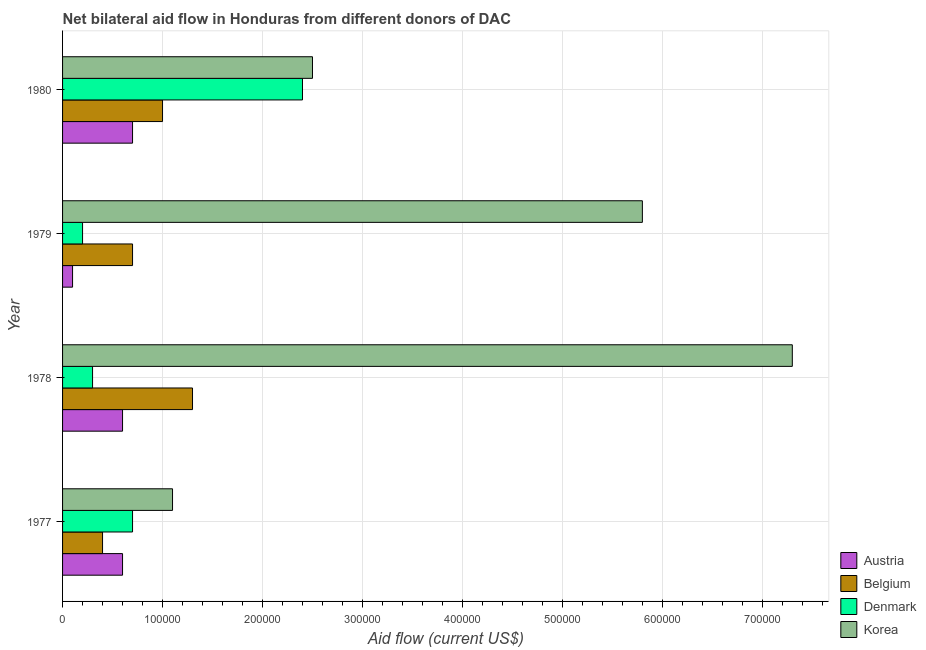How many different coloured bars are there?
Your answer should be very brief. 4. Are the number of bars per tick equal to the number of legend labels?
Your answer should be compact. Yes. Are the number of bars on each tick of the Y-axis equal?
Your answer should be compact. Yes. How many bars are there on the 1st tick from the top?
Keep it short and to the point. 4. How many bars are there on the 4th tick from the bottom?
Provide a short and direct response. 4. What is the label of the 3rd group of bars from the top?
Offer a very short reply. 1978. In how many cases, is the number of bars for a given year not equal to the number of legend labels?
Provide a succinct answer. 0. What is the amount of aid given by belgium in 1979?
Your answer should be compact. 7.00e+04. Across all years, what is the maximum amount of aid given by denmark?
Provide a succinct answer. 2.40e+05. Across all years, what is the minimum amount of aid given by denmark?
Ensure brevity in your answer.  2.00e+04. In which year was the amount of aid given by korea maximum?
Give a very brief answer. 1978. In which year was the amount of aid given by austria minimum?
Provide a short and direct response. 1979. What is the total amount of aid given by denmark in the graph?
Ensure brevity in your answer.  3.60e+05. What is the difference between the amount of aid given by denmark in 1979 and that in 1980?
Provide a succinct answer. -2.20e+05. What is the difference between the amount of aid given by korea in 1980 and the amount of aid given by austria in 1979?
Offer a very short reply. 2.40e+05. In the year 1979, what is the difference between the amount of aid given by korea and amount of aid given by belgium?
Your answer should be compact. 5.10e+05. What is the ratio of the amount of aid given by belgium in 1977 to that in 1979?
Make the answer very short. 0.57. Is the difference between the amount of aid given by korea in 1979 and 1980 greater than the difference between the amount of aid given by belgium in 1979 and 1980?
Your answer should be compact. Yes. What is the difference between the highest and the second highest amount of aid given by belgium?
Your answer should be compact. 3.00e+04. What is the difference between the highest and the lowest amount of aid given by austria?
Make the answer very short. 6.00e+04. Is it the case that in every year, the sum of the amount of aid given by denmark and amount of aid given by korea is greater than the sum of amount of aid given by austria and amount of aid given by belgium?
Provide a succinct answer. Yes. What does the 2nd bar from the top in 1979 represents?
Your answer should be very brief. Denmark. Is it the case that in every year, the sum of the amount of aid given by austria and amount of aid given by belgium is greater than the amount of aid given by denmark?
Offer a terse response. No. What is the difference between two consecutive major ticks on the X-axis?
Make the answer very short. 1.00e+05. Does the graph contain any zero values?
Your response must be concise. No. Where does the legend appear in the graph?
Give a very brief answer. Bottom right. How many legend labels are there?
Your answer should be very brief. 4. What is the title of the graph?
Offer a very short reply. Net bilateral aid flow in Honduras from different donors of DAC. Does "Rule based governance" appear as one of the legend labels in the graph?
Ensure brevity in your answer.  No. What is the label or title of the X-axis?
Your answer should be compact. Aid flow (current US$). What is the label or title of the Y-axis?
Provide a succinct answer. Year. What is the Aid flow (current US$) in Belgium in 1977?
Your answer should be very brief. 4.00e+04. What is the Aid flow (current US$) in Austria in 1978?
Offer a terse response. 6.00e+04. What is the Aid flow (current US$) of Korea in 1978?
Give a very brief answer. 7.30e+05. What is the Aid flow (current US$) in Austria in 1979?
Give a very brief answer. 10000. What is the Aid flow (current US$) in Korea in 1979?
Your response must be concise. 5.80e+05. What is the Aid flow (current US$) in Belgium in 1980?
Make the answer very short. 1.00e+05. What is the Aid flow (current US$) of Korea in 1980?
Ensure brevity in your answer.  2.50e+05. Across all years, what is the maximum Aid flow (current US$) of Austria?
Your response must be concise. 7.00e+04. Across all years, what is the maximum Aid flow (current US$) in Denmark?
Make the answer very short. 2.40e+05. Across all years, what is the maximum Aid flow (current US$) of Korea?
Offer a very short reply. 7.30e+05. Across all years, what is the minimum Aid flow (current US$) of Belgium?
Offer a very short reply. 4.00e+04. Across all years, what is the minimum Aid flow (current US$) of Denmark?
Your answer should be very brief. 2.00e+04. What is the total Aid flow (current US$) in Austria in the graph?
Keep it short and to the point. 2.00e+05. What is the total Aid flow (current US$) of Korea in the graph?
Ensure brevity in your answer.  1.67e+06. What is the difference between the Aid flow (current US$) of Denmark in 1977 and that in 1978?
Make the answer very short. 4.00e+04. What is the difference between the Aid flow (current US$) in Korea in 1977 and that in 1978?
Offer a terse response. -6.20e+05. What is the difference between the Aid flow (current US$) of Korea in 1977 and that in 1979?
Offer a terse response. -4.70e+05. What is the difference between the Aid flow (current US$) of Austria in 1977 and that in 1980?
Make the answer very short. -10000. What is the difference between the Aid flow (current US$) in Belgium in 1978 and that in 1979?
Make the answer very short. 6.00e+04. What is the difference between the Aid flow (current US$) in Austria in 1978 and that in 1980?
Keep it short and to the point. -10000. What is the difference between the Aid flow (current US$) in Belgium in 1978 and that in 1980?
Offer a very short reply. 3.00e+04. What is the difference between the Aid flow (current US$) of Denmark in 1978 and that in 1980?
Your response must be concise. -2.10e+05. What is the difference between the Aid flow (current US$) of Korea in 1978 and that in 1980?
Provide a succinct answer. 4.80e+05. What is the difference between the Aid flow (current US$) of Austria in 1979 and that in 1980?
Make the answer very short. -6.00e+04. What is the difference between the Aid flow (current US$) of Denmark in 1979 and that in 1980?
Provide a short and direct response. -2.20e+05. What is the difference between the Aid flow (current US$) in Korea in 1979 and that in 1980?
Provide a succinct answer. 3.30e+05. What is the difference between the Aid flow (current US$) of Austria in 1977 and the Aid flow (current US$) of Belgium in 1978?
Your answer should be compact. -7.00e+04. What is the difference between the Aid flow (current US$) of Austria in 1977 and the Aid flow (current US$) of Korea in 1978?
Your response must be concise. -6.70e+05. What is the difference between the Aid flow (current US$) in Belgium in 1977 and the Aid flow (current US$) in Denmark in 1978?
Ensure brevity in your answer.  10000. What is the difference between the Aid flow (current US$) of Belgium in 1977 and the Aid flow (current US$) of Korea in 1978?
Offer a very short reply. -6.90e+05. What is the difference between the Aid flow (current US$) of Denmark in 1977 and the Aid flow (current US$) of Korea in 1978?
Your answer should be very brief. -6.60e+05. What is the difference between the Aid flow (current US$) of Austria in 1977 and the Aid flow (current US$) of Belgium in 1979?
Make the answer very short. -10000. What is the difference between the Aid flow (current US$) of Austria in 1977 and the Aid flow (current US$) of Korea in 1979?
Ensure brevity in your answer.  -5.20e+05. What is the difference between the Aid flow (current US$) in Belgium in 1977 and the Aid flow (current US$) in Korea in 1979?
Your answer should be compact. -5.40e+05. What is the difference between the Aid flow (current US$) in Denmark in 1977 and the Aid flow (current US$) in Korea in 1979?
Your answer should be very brief. -5.10e+05. What is the difference between the Aid flow (current US$) in Austria in 1977 and the Aid flow (current US$) in Belgium in 1980?
Your answer should be compact. -4.00e+04. What is the difference between the Aid flow (current US$) in Austria in 1977 and the Aid flow (current US$) in Denmark in 1980?
Your answer should be very brief. -1.80e+05. What is the difference between the Aid flow (current US$) of Belgium in 1977 and the Aid flow (current US$) of Denmark in 1980?
Keep it short and to the point. -2.00e+05. What is the difference between the Aid flow (current US$) of Belgium in 1977 and the Aid flow (current US$) of Korea in 1980?
Ensure brevity in your answer.  -2.10e+05. What is the difference between the Aid flow (current US$) of Austria in 1978 and the Aid flow (current US$) of Denmark in 1979?
Your answer should be very brief. 4.00e+04. What is the difference between the Aid flow (current US$) in Austria in 1978 and the Aid flow (current US$) in Korea in 1979?
Provide a short and direct response. -5.20e+05. What is the difference between the Aid flow (current US$) of Belgium in 1978 and the Aid flow (current US$) of Korea in 1979?
Your response must be concise. -4.50e+05. What is the difference between the Aid flow (current US$) of Denmark in 1978 and the Aid flow (current US$) of Korea in 1979?
Your answer should be very brief. -5.50e+05. What is the difference between the Aid flow (current US$) of Austria in 1978 and the Aid flow (current US$) of Belgium in 1980?
Your answer should be compact. -4.00e+04. What is the difference between the Aid flow (current US$) in Belgium in 1978 and the Aid flow (current US$) in Korea in 1980?
Your answer should be very brief. -1.20e+05. What is the difference between the Aid flow (current US$) of Austria in 1979 and the Aid flow (current US$) of Belgium in 1980?
Offer a terse response. -9.00e+04. What is the difference between the Aid flow (current US$) in Austria in 1979 and the Aid flow (current US$) in Denmark in 1980?
Provide a short and direct response. -2.30e+05. What is the difference between the Aid flow (current US$) of Austria in 1979 and the Aid flow (current US$) of Korea in 1980?
Offer a terse response. -2.40e+05. What is the average Aid flow (current US$) in Austria per year?
Provide a succinct answer. 5.00e+04. What is the average Aid flow (current US$) in Belgium per year?
Your answer should be compact. 8.50e+04. What is the average Aid flow (current US$) in Korea per year?
Offer a very short reply. 4.18e+05. In the year 1977, what is the difference between the Aid flow (current US$) in Austria and Aid flow (current US$) in Belgium?
Keep it short and to the point. 2.00e+04. In the year 1977, what is the difference between the Aid flow (current US$) of Austria and Aid flow (current US$) of Denmark?
Make the answer very short. -10000. In the year 1977, what is the difference between the Aid flow (current US$) of Belgium and Aid flow (current US$) of Korea?
Ensure brevity in your answer.  -7.00e+04. In the year 1978, what is the difference between the Aid flow (current US$) of Austria and Aid flow (current US$) of Denmark?
Your answer should be compact. 3.00e+04. In the year 1978, what is the difference between the Aid flow (current US$) in Austria and Aid flow (current US$) in Korea?
Offer a very short reply. -6.70e+05. In the year 1978, what is the difference between the Aid flow (current US$) of Belgium and Aid flow (current US$) of Korea?
Your answer should be very brief. -6.00e+05. In the year 1978, what is the difference between the Aid flow (current US$) in Denmark and Aid flow (current US$) in Korea?
Your response must be concise. -7.00e+05. In the year 1979, what is the difference between the Aid flow (current US$) in Austria and Aid flow (current US$) in Belgium?
Provide a short and direct response. -6.00e+04. In the year 1979, what is the difference between the Aid flow (current US$) of Austria and Aid flow (current US$) of Korea?
Provide a succinct answer. -5.70e+05. In the year 1979, what is the difference between the Aid flow (current US$) in Belgium and Aid flow (current US$) in Korea?
Provide a succinct answer. -5.10e+05. In the year 1979, what is the difference between the Aid flow (current US$) of Denmark and Aid flow (current US$) of Korea?
Keep it short and to the point. -5.60e+05. In the year 1980, what is the difference between the Aid flow (current US$) in Austria and Aid flow (current US$) in Belgium?
Provide a short and direct response. -3.00e+04. In the year 1980, what is the difference between the Aid flow (current US$) of Austria and Aid flow (current US$) of Denmark?
Offer a very short reply. -1.70e+05. In the year 1980, what is the difference between the Aid flow (current US$) in Austria and Aid flow (current US$) in Korea?
Provide a short and direct response. -1.80e+05. In the year 1980, what is the difference between the Aid flow (current US$) in Belgium and Aid flow (current US$) in Denmark?
Keep it short and to the point. -1.40e+05. In the year 1980, what is the difference between the Aid flow (current US$) of Belgium and Aid flow (current US$) of Korea?
Your answer should be compact. -1.50e+05. In the year 1980, what is the difference between the Aid flow (current US$) in Denmark and Aid flow (current US$) in Korea?
Your answer should be compact. -10000. What is the ratio of the Aid flow (current US$) in Austria in 1977 to that in 1978?
Offer a very short reply. 1. What is the ratio of the Aid flow (current US$) in Belgium in 1977 to that in 1978?
Make the answer very short. 0.31. What is the ratio of the Aid flow (current US$) in Denmark in 1977 to that in 1978?
Offer a very short reply. 2.33. What is the ratio of the Aid flow (current US$) in Korea in 1977 to that in 1978?
Make the answer very short. 0.15. What is the ratio of the Aid flow (current US$) in Korea in 1977 to that in 1979?
Offer a terse response. 0.19. What is the ratio of the Aid flow (current US$) of Austria in 1977 to that in 1980?
Offer a very short reply. 0.86. What is the ratio of the Aid flow (current US$) of Belgium in 1977 to that in 1980?
Your answer should be very brief. 0.4. What is the ratio of the Aid flow (current US$) of Denmark in 1977 to that in 1980?
Ensure brevity in your answer.  0.29. What is the ratio of the Aid flow (current US$) in Korea in 1977 to that in 1980?
Your response must be concise. 0.44. What is the ratio of the Aid flow (current US$) in Belgium in 1978 to that in 1979?
Provide a succinct answer. 1.86. What is the ratio of the Aid flow (current US$) of Denmark in 1978 to that in 1979?
Offer a very short reply. 1.5. What is the ratio of the Aid flow (current US$) in Korea in 1978 to that in 1979?
Ensure brevity in your answer.  1.26. What is the ratio of the Aid flow (current US$) of Belgium in 1978 to that in 1980?
Your response must be concise. 1.3. What is the ratio of the Aid flow (current US$) in Denmark in 1978 to that in 1980?
Ensure brevity in your answer.  0.12. What is the ratio of the Aid flow (current US$) in Korea in 1978 to that in 1980?
Keep it short and to the point. 2.92. What is the ratio of the Aid flow (current US$) of Austria in 1979 to that in 1980?
Your answer should be very brief. 0.14. What is the ratio of the Aid flow (current US$) in Denmark in 1979 to that in 1980?
Provide a succinct answer. 0.08. What is the ratio of the Aid flow (current US$) in Korea in 1979 to that in 1980?
Offer a very short reply. 2.32. What is the difference between the highest and the second highest Aid flow (current US$) of Belgium?
Ensure brevity in your answer.  3.00e+04. What is the difference between the highest and the second highest Aid flow (current US$) of Denmark?
Your response must be concise. 1.70e+05. What is the difference between the highest and the lowest Aid flow (current US$) of Austria?
Your answer should be compact. 6.00e+04. What is the difference between the highest and the lowest Aid flow (current US$) in Korea?
Your answer should be very brief. 6.20e+05. 